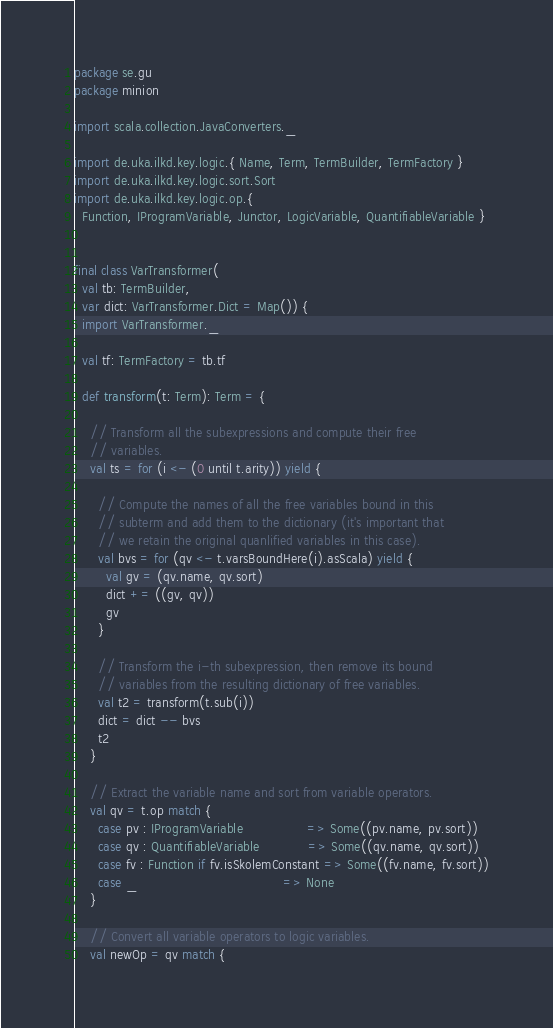<code> <loc_0><loc_0><loc_500><loc_500><_Scala_>package se.gu
package minion

import scala.collection.JavaConverters._

import de.uka.ilkd.key.logic.{ Name, Term, TermBuilder, TermFactory }
import de.uka.ilkd.key.logic.sort.Sort
import de.uka.ilkd.key.logic.op.{
  Function, IProgramVariable, Junctor, LogicVariable, QuantifiableVariable }


final class VarTransformer(
  val tb: TermBuilder,
  var dict: VarTransformer.Dict = Map()) {
  import VarTransformer._

  val tf: TermFactory = tb.tf

  def transform(t: Term): Term = {

    // Transform all the subexpressions and compute their free
    // variables.
    val ts = for (i <- (0 until t.arity)) yield {

      // Compute the names of all the free variables bound in this
      // subterm and add them to the dictionary (it's important that
      // we retain the original quanlified variables in this case).
      val bvs = for (qv <- t.varsBoundHere(i).asScala) yield {
        val gv = (qv.name, qv.sort)
        dict += ((gv, qv))
        gv
      }

      // Transform the i-th subexpression, then remove its bound
      // variables from the resulting dictionary of free variables.
      val t2 = transform(t.sub(i))
      dict = dict -- bvs
      t2
    }

    // Extract the variable name and sort from variable operators.
    val qv = t.op match {
      case pv : IProgramVariable                => Some((pv.name, pv.sort))
      case qv : QuantifiableVariable            => Some((qv.name, qv.sort))
      case fv : Function if fv.isSkolemConstant => Some((fv.name, fv.sort))
      case _                                    => None
    }

    // Convert all variable operators to logic variables.
    val newOp = qv match {</code> 